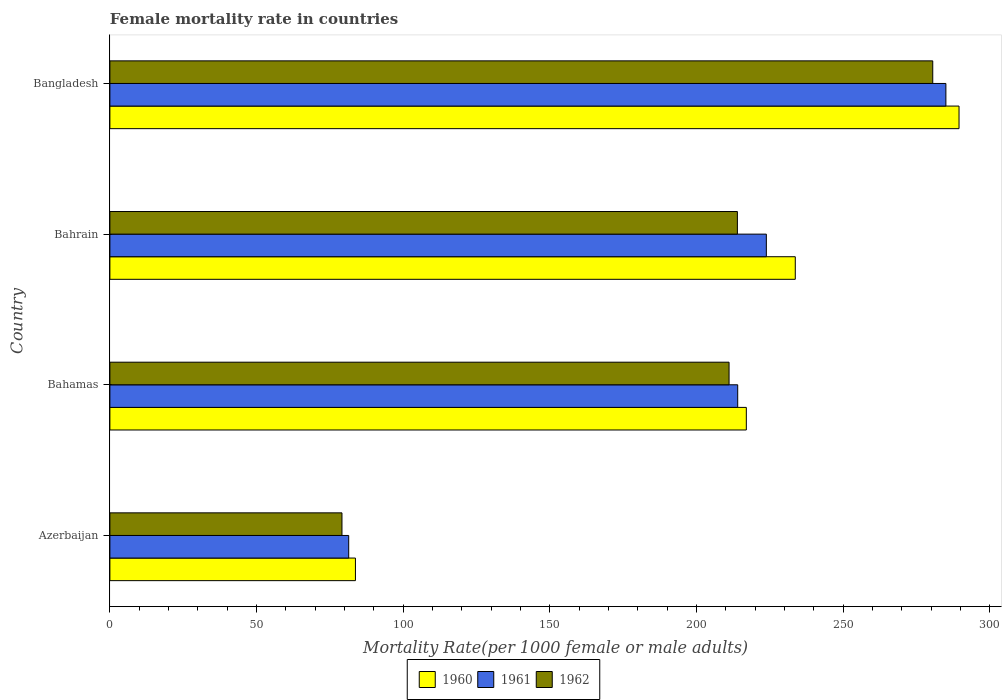How many bars are there on the 2nd tick from the top?
Offer a terse response. 3. How many bars are there on the 2nd tick from the bottom?
Provide a succinct answer. 3. What is the label of the 1st group of bars from the top?
Provide a short and direct response. Bangladesh. What is the female mortality rate in 1960 in Bangladesh?
Ensure brevity in your answer.  289.55. Across all countries, what is the maximum female mortality rate in 1960?
Offer a terse response. 289.55. Across all countries, what is the minimum female mortality rate in 1961?
Offer a terse response. 81.43. In which country was the female mortality rate in 1961 minimum?
Your response must be concise. Azerbaijan. What is the total female mortality rate in 1960 in the graph?
Offer a very short reply. 824.01. What is the difference between the female mortality rate in 1961 in Azerbaijan and that in Bangladesh?
Offer a terse response. -203.64. What is the difference between the female mortality rate in 1961 in Bangladesh and the female mortality rate in 1960 in Azerbaijan?
Offer a very short reply. 201.34. What is the average female mortality rate in 1962 per country?
Make the answer very short. 196.21. What is the difference between the female mortality rate in 1961 and female mortality rate in 1960 in Azerbaijan?
Your response must be concise. -2.29. In how many countries, is the female mortality rate in 1961 greater than 30 ?
Ensure brevity in your answer.  4. What is the ratio of the female mortality rate in 1962 in Azerbaijan to that in Bahamas?
Offer a terse response. 0.37. Is the difference between the female mortality rate in 1961 in Bahamas and Bangladesh greater than the difference between the female mortality rate in 1960 in Bahamas and Bangladesh?
Make the answer very short. Yes. What is the difference between the highest and the second highest female mortality rate in 1960?
Offer a terse response. 55.84. What is the difference between the highest and the lowest female mortality rate in 1960?
Your answer should be very brief. 205.82. In how many countries, is the female mortality rate in 1960 greater than the average female mortality rate in 1960 taken over all countries?
Provide a short and direct response. 3. What does the 2nd bar from the bottom in Bahrain represents?
Your response must be concise. 1961. How many bars are there?
Give a very brief answer. 12. How many countries are there in the graph?
Your answer should be compact. 4. Are the values on the major ticks of X-axis written in scientific E-notation?
Make the answer very short. No. Does the graph contain any zero values?
Your response must be concise. No. Where does the legend appear in the graph?
Provide a succinct answer. Bottom center. How many legend labels are there?
Keep it short and to the point. 3. What is the title of the graph?
Provide a short and direct response. Female mortality rate in countries. What is the label or title of the X-axis?
Provide a succinct answer. Mortality Rate(per 1000 female or male adults). What is the Mortality Rate(per 1000 female or male adults) of 1960 in Azerbaijan?
Give a very brief answer. 83.73. What is the Mortality Rate(per 1000 female or male adults) of 1961 in Azerbaijan?
Your answer should be compact. 81.43. What is the Mortality Rate(per 1000 female or male adults) of 1962 in Azerbaijan?
Provide a short and direct response. 79.14. What is the Mortality Rate(per 1000 female or male adults) in 1960 in Bahamas?
Offer a terse response. 217.02. What is the Mortality Rate(per 1000 female or male adults) of 1961 in Bahamas?
Offer a terse response. 214.07. What is the Mortality Rate(per 1000 female or male adults) in 1962 in Bahamas?
Your answer should be very brief. 211.13. What is the Mortality Rate(per 1000 female or male adults) in 1960 in Bahrain?
Make the answer very short. 233.71. What is the Mortality Rate(per 1000 female or male adults) of 1961 in Bahrain?
Offer a terse response. 223.84. What is the Mortality Rate(per 1000 female or male adults) of 1962 in Bahrain?
Offer a terse response. 213.97. What is the Mortality Rate(per 1000 female or male adults) of 1960 in Bangladesh?
Give a very brief answer. 289.55. What is the Mortality Rate(per 1000 female or male adults) in 1961 in Bangladesh?
Your answer should be compact. 285.07. What is the Mortality Rate(per 1000 female or male adults) in 1962 in Bangladesh?
Offer a very short reply. 280.59. Across all countries, what is the maximum Mortality Rate(per 1000 female or male adults) of 1960?
Provide a succinct answer. 289.55. Across all countries, what is the maximum Mortality Rate(per 1000 female or male adults) in 1961?
Your answer should be compact. 285.07. Across all countries, what is the maximum Mortality Rate(per 1000 female or male adults) of 1962?
Offer a very short reply. 280.59. Across all countries, what is the minimum Mortality Rate(per 1000 female or male adults) in 1960?
Offer a terse response. 83.73. Across all countries, what is the minimum Mortality Rate(per 1000 female or male adults) of 1961?
Your answer should be compact. 81.43. Across all countries, what is the minimum Mortality Rate(per 1000 female or male adults) in 1962?
Your answer should be very brief. 79.14. What is the total Mortality Rate(per 1000 female or male adults) in 1960 in the graph?
Give a very brief answer. 824.01. What is the total Mortality Rate(per 1000 female or male adults) in 1961 in the graph?
Offer a very short reply. 804.42. What is the total Mortality Rate(per 1000 female or male adults) of 1962 in the graph?
Provide a succinct answer. 784.83. What is the difference between the Mortality Rate(per 1000 female or male adults) in 1960 in Azerbaijan and that in Bahamas?
Provide a short and direct response. -133.29. What is the difference between the Mortality Rate(per 1000 female or male adults) in 1961 in Azerbaijan and that in Bahamas?
Provide a short and direct response. -132.64. What is the difference between the Mortality Rate(per 1000 female or male adults) of 1962 in Azerbaijan and that in Bahamas?
Provide a succinct answer. -131.99. What is the difference between the Mortality Rate(per 1000 female or male adults) of 1960 in Azerbaijan and that in Bahrain?
Offer a very short reply. -149.99. What is the difference between the Mortality Rate(per 1000 female or male adults) in 1961 in Azerbaijan and that in Bahrain?
Offer a terse response. -142.41. What is the difference between the Mortality Rate(per 1000 female or male adults) in 1962 in Azerbaijan and that in Bahrain?
Your response must be concise. -134.83. What is the difference between the Mortality Rate(per 1000 female or male adults) in 1960 in Azerbaijan and that in Bangladesh?
Provide a succinct answer. -205.82. What is the difference between the Mortality Rate(per 1000 female or male adults) in 1961 in Azerbaijan and that in Bangladesh?
Provide a short and direct response. -203.64. What is the difference between the Mortality Rate(per 1000 female or male adults) of 1962 in Azerbaijan and that in Bangladesh?
Your response must be concise. -201.45. What is the difference between the Mortality Rate(per 1000 female or male adults) in 1960 in Bahamas and that in Bahrain?
Offer a very short reply. -16.7. What is the difference between the Mortality Rate(per 1000 female or male adults) of 1961 in Bahamas and that in Bahrain?
Offer a very short reply. -9.77. What is the difference between the Mortality Rate(per 1000 female or male adults) of 1962 in Bahamas and that in Bahrain?
Provide a succinct answer. -2.84. What is the difference between the Mortality Rate(per 1000 female or male adults) of 1960 in Bahamas and that in Bangladesh?
Your answer should be compact. -72.53. What is the difference between the Mortality Rate(per 1000 female or male adults) of 1961 in Bahamas and that in Bangladesh?
Make the answer very short. -70.99. What is the difference between the Mortality Rate(per 1000 female or male adults) in 1962 in Bahamas and that in Bangladesh?
Ensure brevity in your answer.  -69.46. What is the difference between the Mortality Rate(per 1000 female or male adults) of 1960 in Bahrain and that in Bangladesh?
Your answer should be very brief. -55.84. What is the difference between the Mortality Rate(per 1000 female or male adults) in 1961 in Bahrain and that in Bangladesh?
Give a very brief answer. -61.23. What is the difference between the Mortality Rate(per 1000 female or male adults) of 1962 in Bahrain and that in Bangladesh?
Make the answer very short. -66.62. What is the difference between the Mortality Rate(per 1000 female or male adults) of 1960 in Azerbaijan and the Mortality Rate(per 1000 female or male adults) of 1961 in Bahamas?
Offer a terse response. -130.35. What is the difference between the Mortality Rate(per 1000 female or male adults) of 1960 in Azerbaijan and the Mortality Rate(per 1000 female or male adults) of 1962 in Bahamas?
Give a very brief answer. -127.4. What is the difference between the Mortality Rate(per 1000 female or male adults) of 1961 in Azerbaijan and the Mortality Rate(per 1000 female or male adults) of 1962 in Bahamas?
Ensure brevity in your answer.  -129.7. What is the difference between the Mortality Rate(per 1000 female or male adults) in 1960 in Azerbaijan and the Mortality Rate(per 1000 female or male adults) in 1961 in Bahrain?
Provide a short and direct response. -140.11. What is the difference between the Mortality Rate(per 1000 female or male adults) in 1960 in Azerbaijan and the Mortality Rate(per 1000 female or male adults) in 1962 in Bahrain?
Give a very brief answer. -130.24. What is the difference between the Mortality Rate(per 1000 female or male adults) of 1961 in Azerbaijan and the Mortality Rate(per 1000 female or male adults) of 1962 in Bahrain?
Provide a succinct answer. -132.54. What is the difference between the Mortality Rate(per 1000 female or male adults) in 1960 in Azerbaijan and the Mortality Rate(per 1000 female or male adults) in 1961 in Bangladesh?
Your response must be concise. -201.34. What is the difference between the Mortality Rate(per 1000 female or male adults) in 1960 in Azerbaijan and the Mortality Rate(per 1000 female or male adults) in 1962 in Bangladesh?
Ensure brevity in your answer.  -196.86. What is the difference between the Mortality Rate(per 1000 female or male adults) of 1961 in Azerbaijan and the Mortality Rate(per 1000 female or male adults) of 1962 in Bangladesh?
Offer a very short reply. -199.16. What is the difference between the Mortality Rate(per 1000 female or male adults) in 1960 in Bahamas and the Mortality Rate(per 1000 female or male adults) in 1961 in Bahrain?
Make the answer very short. -6.82. What is the difference between the Mortality Rate(per 1000 female or male adults) of 1960 in Bahamas and the Mortality Rate(per 1000 female or male adults) of 1962 in Bahrain?
Offer a very short reply. 3.05. What is the difference between the Mortality Rate(per 1000 female or male adults) of 1961 in Bahamas and the Mortality Rate(per 1000 female or male adults) of 1962 in Bahrain?
Provide a succinct answer. 0.11. What is the difference between the Mortality Rate(per 1000 female or male adults) in 1960 in Bahamas and the Mortality Rate(per 1000 female or male adults) in 1961 in Bangladesh?
Make the answer very short. -68.05. What is the difference between the Mortality Rate(per 1000 female or male adults) in 1960 in Bahamas and the Mortality Rate(per 1000 female or male adults) in 1962 in Bangladesh?
Offer a very short reply. -63.57. What is the difference between the Mortality Rate(per 1000 female or male adults) of 1961 in Bahamas and the Mortality Rate(per 1000 female or male adults) of 1962 in Bangladesh?
Give a very brief answer. -66.51. What is the difference between the Mortality Rate(per 1000 female or male adults) in 1960 in Bahrain and the Mortality Rate(per 1000 female or male adults) in 1961 in Bangladesh?
Provide a short and direct response. -51.35. What is the difference between the Mortality Rate(per 1000 female or male adults) of 1960 in Bahrain and the Mortality Rate(per 1000 female or male adults) of 1962 in Bangladesh?
Offer a terse response. -46.88. What is the difference between the Mortality Rate(per 1000 female or male adults) of 1961 in Bahrain and the Mortality Rate(per 1000 female or male adults) of 1962 in Bangladesh?
Keep it short and to the point. -56.75. What is the average Mortality Rate(per 1000 female or male adults) of 1960 per country?
Your response must be concise. 206. What is the average Mortality Rate(per 1000 female or male adults) of 1961 per country?
Provide a succinct answer. 201.1. What is the average Mortality Rate(per 1000 female or male adults) of 1962 per country?
Ensure brevity in your answer.  196.21. What is the difference between the Mortality Rate(per 1000 female or male adults) of 1960 and Mortality Rate(per 1000 female or male adults) of 1961 in Azerbaijan?
Provide a succinct answer. 2.29. What is the difference between the Mortality Rate(per 1000 female or male adults) in 1960 and Mortality Rate(per 1000 female or male adults) in 1962 in Azerbaijan?
Provide a short and direct response. 4.59. What is the difference between the Mortality Rate(per 1000 female or male adults) in 1961 and Mortality Rate(per 1000 female or male adults) in 1962 in Azerbaijan?
Give a very brief answer. 2.29. What is the difference between the Mortality Rate(per 1000 female or male adults) of 1960 and Mortality Rate(per 1000 female or male adults) of 1961 in Bahamas?
Your answer should be very brief. 2.94. What is the difference between the Mortality Rate(per 1000 female or male adults) of 1960 and Mortality Rate(per 1000 female or male adults) of 1962 in Bahamas?
Your answer should be very brief. 5.88. What is the difference between the Mortality Rate(per 1000 female or male adults) in 1961 and Mortality Rate(per 1000 female or male adults) in 1962 in Bahamas?
Offer a very short reply. 2.94. What is the difference between the Mortality Rate(per 1000 female or male adults) in 1960 and Mortality Rate(per 1000 female or male adults) in 1961 in Bahrain?
Offer a terse response. 9.87. What is the difference between the Mortality Rate(per 1000 female or male adults) in 1960 and Mortality Rate(per 1000 female or male adults) in 1962 in Bahrain?
Keep it short and to the point. 19.74. What is the difference between the Mortality Rate(per 1000 female or male adults) of 1961 and Mortality Rate(per 1000 female or male adults) of 1962 in Bahrain?
Your answer should be very brief. 9.87. What is the difference between the Mortality Rate(per 1000 female or male adults) of 1960 and Mortality Rate(per 1000 female or male adults) of 1961 in Bangladesh?
Offer a very short reply. 4.48. What is the difference between the Mortality Rate(per 1000 female or male adults) of 1960 and Mortality Rate(per 1000 female or male adults) of 1962 in Bangladesh?
Give a very brief answer. 8.96. What is the difference between the Mortality Rate(per 1000 female or male adults) of 1961 and Mortality Rate(per 1000 female or male adults) of 1962 in Bangladesh?
Make the answer very short. 4.48. What is the ratio of the Mortality Rate(per 1000 female or male adults) in 1960 in Azerbaijan to that in Bahamas?
Provide a succinct answer. 0.39. What is the ratio of the Mortality Rate(per 1000 female or male adults) of 1961 in Azerbaijan to that in Bahamas?
Your answer should be compact. 0.38. What is the ratio of the Mortality Rate(per 1000 female or male adults) in 1962 in Azerbaijan to that in Bahamas?
Offer a terse response. 0.37. What is the ratio of the Mortality Rate(per 1000 female or male adults) in 1960 in Azerbaijan to that in Bahrain?
Your answer should be very brief. 0.36. What is the ratio of the Mortality Rate(per 1000 female or male adults) of 1961 in Azerbaijan to that in Bahrain?
Make the answer very short. 0.36. What is the ratio of the Mortality Rate(per 1000 female or male adults) in 1962 in Azerbaijan to that in Bahrain?
Your response must be concise. 0.37. What is the ratio of the Mortality Rate(per 1000 female or male adults) of 1960 in Azerbaijan to that in Bangladesh?
Keep it short and to the point. 0.29. What is the ratio of the Mortality Rate(per 1000 female or male adults) in 1961 in Azerbaijan to that in Bangladesh?
Your response must be concise. 0.29. What is the ratio of the Mortality Rate(per 1000 female or male adults) in 1962 in Azerbaijan to that in Bangladesh?
Make the answer very short. 0.28. What is the ratio of the Mortality Rate(per 1000 female or male adults) in 1961 in Bahamas to that in Bahrain?
Keep it short and to the point. 0.96. What is the ratio of the Mortality Rate(per 1000 female or male adults) of 1962 in Bahamas to that in Bahrain?
Your response must be concise. 0.99. What is the ratio of the Mortality Rate(per 1000 female or male adults) in 1960 in Bahamas to that in Bangladesh?
Provide a succinct answer. 0.75. What is the ratio of the Mortality Rate(per 1000 female or male adults) in 1961 in Bahamas to that in Bangladesh?
Make the answer very short. 0.75. What is the ratio of the Mortality Rate(per 1000 female or male adults) in 1962 in Bahamas to that in Bangladesh?
Your response must be concise. 0.75. What is the ratio of the Mortality Rate(per 1000 female or male adults) in 1960 in Bahrain to that in Bangladesh?
Give a very brief answer. 0.81. What is the ratio of the Mortality Rate(per 1000 female or male adults) in 1961 in Bahrain to that in Bangladesh?
Your answer should be compact. 0.79. What is the ratio of the Mortality Rate(per 1000 female or male adults) of 1962 in Bahrain to that in Bangladesh?
Offer a terse response. 0.76. What is the difference between the highest and the second highest Mortality Rate(per 1000 female or male adults) in 1960?
Offer a very short reply. 55.84. What is the difference between the highest and the second highest Mortality Rate(per 1000 female or male adults) in 1961?
Offer a terse response. 61.23. What is the difference between the highest and the second highest Mortality Rate(per 1000 female or male adults) of 1962?
Offer a very short reply. 66.62. What is the difference between the highest and the lowest Mortality Rate(per 1000 female or male adults) of 1960?
Provide a succinct answer. 205.82. What is the difference between the highest and the lowest Mortality Rate(per 1000 female or male adults) in 1961?
Make the answer very short. 203.64. What is the difference between the highest and the lowest Mortality Rate(per 1000 female or male adults) of 1962?
Provide a succinct answer. 201.45. 